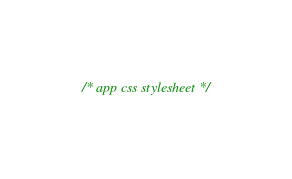<code> <loc_0><loc_0><loc_500><loc_500><_CSS_>/* app css stylesheet */
</code> 